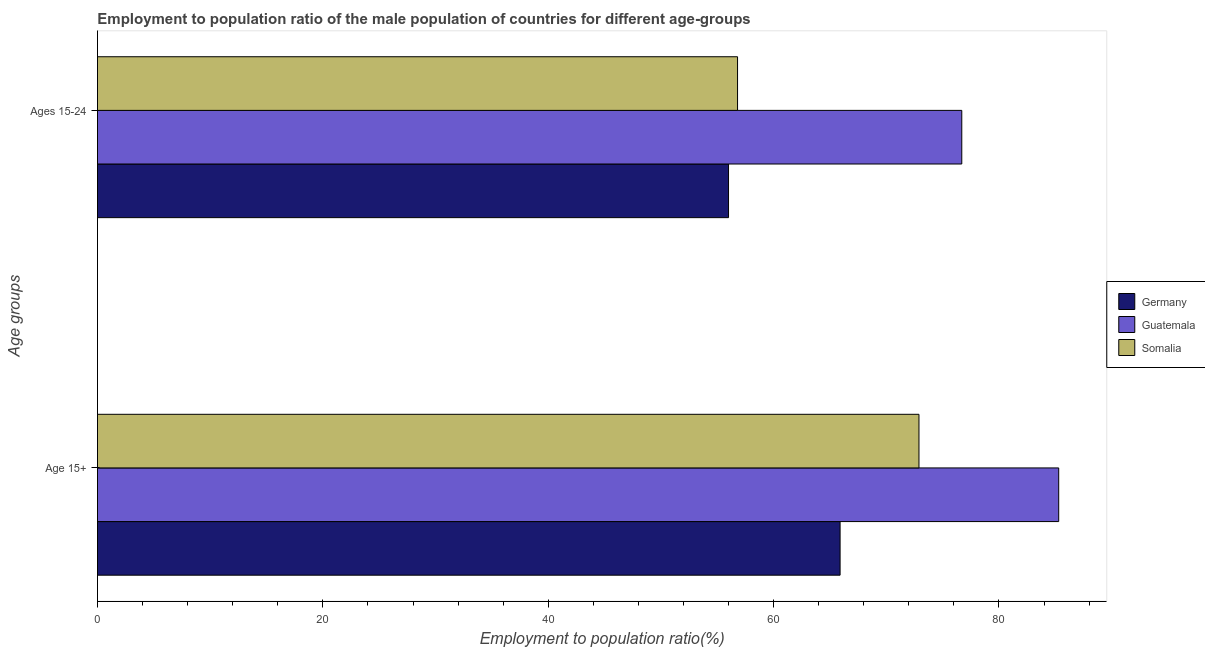How many different coloured bars are there?
Your response must be concise. 3. Are the number of bars per tick equal to the number of legend labels?
Offer a very short reply. Yes. Are the number of bars on each tick of the Y-axis equal?
Offer a very short reply. Yes. How many bars are there on the 2nd tick from the top?
Provide a succinct answer. 3. What is the label of the 2nd group of bars from the top?
Ensure brevity in your answer.  Age 15+. What is the employment to population ratio(age 15+) in Guatemala?
Your answer should be very brief. 85.3. Across all countries, what is the maximum employment to population ratio(age 15-24)?
Provide a succinct answer. 76.7. Across all countries, what is the minimum employment to population ratio(age 15+)?
Your answer should be very brief. 65.9. In which country was the employment to population ratio(age 15+) maximum?
Your answer should be very brief. Guatemala. In which country was the employment to population ratio(age 15+) minimum?
Keep it short and to the point. Germany. What is the total employment to population ratio(age 15-24) in the graph?
Offer a terse response. 189.5. What is the difference between the employment to population ratio(age 15-24) in Somalia and that in Germany?
Make the answer very short. 0.8. What is the difference between the employment to population ratio(age 15+) in Somalia and the employment to population ratio(age 15-24) in Guatemala?
Offer a terse response. -3.8. What is the average employment to population ratio(age 15-24) per country?
Give a very brief answer. 63.17. What is the difference between the employment to population ratio(age 15+) and employment to population ratio(age 15-24) in Guatemala?
Provide a short and direct response. 8.6. What is the ratio of the employment to population ratio(age 15+) in Guatemala to that in Germany?
Make the answer very short. 1.29. Is the employment to population ratio(age 15-24) in Somalia less than that in Germany?
Your response must be concise. No. What does the 1st bar from the top in Ages 15-24 represents?
Provide a succinct answer. Somalia. What does the 1st bar from the bottom in Ages 15-24 represents?
Provide a succinct answer. Germany. How many bars are there?
Keep it short and to the point. 6. How many countries are there in the graph?
Make the answer very short. 3. What is the difference between two consecutive major ticks on the X-axis?
Ensure brevity in your answer.  20. Are the values on the major ticks of X-axis written in scientific E-notation?
Your answer should be compact. No. Does the graph contain any zero values?
Make the answer very short. No. Does the graph contain grids?
Give a very brief answer. No. How are the legend labels stacked?
Provide a succinct answer. Vertical. What is the title of the graph?
Provide a short and direct response. Employment to population ratio of the male population of countries for different age-groups. Does "Macao" appear as one of the legend labels in the graph?
Your response must be concise. No. What is the label or title of the Y-axis?
Provide a short and direct response. Age groups. What is the Employment to population ratio(%) of Germany in Age 15+?
Offer a terse response. 65.9. What is the Employment to population ratio(%) of Guatemala in Age 15+?
Give a very brief answer. 85.3. What is the Employment to population ratio(%) of Somalia in Age 15+?
Offer a terse response. 72.9. What is the Employment to population ratio(%) of Germany in Ages 15-24?
Make the answer very short. 56. What is the Employment to population ratio(%) in Guatemala in Ages 15-24?
Your answer should be very brief. 76.7. What is the Employment to population ratio(%) in Somalia in Ages 15-24?
Offer a very short reply. 56.8. Across all Age groups, what is the maximum Employment to population ratio(%) of Germany?
Offer a very short reply. 65.9. Across all Age groups, what is the maximum Employment to population ratio(%) of Guatemala?
Your answer should be very brief. 85.3. Across all Age groups, what is the maximum Employment to population ratio(%) in Somalia?
Provide a short and direct response. 72.9. Across all Age groups, what is the minimum Employment to population ratio(%) in Germany?
Make the answer very short. 56. Across all Age groups, what is the minimum Employment to population ratio(%) in Guatemala?
Your response must be concise. 76.7. Across all Age groups, what is the minimum Employment to population ratio(%) of Somalia?
Ensure brevity in your answer.  56.8. What is the total Employment to population ratio(%) of Germany in the graph?
Offer a terse response. 121.9. What is the total Employment to population ratio(%) in Guatemala in the graph?
Keep it short and to the point. 162. What is the total Employment to population ratio(%) of Somalia in the graph?
Offer a terse response. 129.7. What is the difference between the Employment to population ratio(%) of Germany in Age 15+ and that in Ages 15-24?
Offer a terse response. 9.9. What is the difference between the Employment to population ratio(%) in Guatemala in Age 15+ and that in Ages 15-24?
Your answer should be compact. 8.6. What is the difference between the Employment to population ratio(%) of Somalia in Age 15+ and that in Ages 15-24?
Ensure brevity in your answer.  16.1. What is the difference between the Employment to population ratio(%) of Germany in Age 15+ and the Employment to population ratio(%) of Somalia in Ages 15-24?
Keep it short and to the point. 9.1. What is the average Employment to population ratio(%) of Germany per Age groups?
Your answer should be compact. 60.95. What is the average Employment to population ratio(%) in Guatemala per Age groups?
Your answer should be very brief. 81. What is the average Employment to population ratio(%) in Somalia per Age groups?
Your answer should be compact. 64.85. What is the difference between the Employment to population ratio(%) in Germany and Employment to population ratio(%) in Guatemala in Age 15+?
Provide a short and direct response. -19.4. What is the difference between the Employment to population ratio(%) in Germany and Employment to population ratio(%) in Somalia in Age 15+?
Provide a succinct answer. -7. What is the difference between the Employment to population ratio(%) of Germany and Employment to population ratio(%) of Guatemala in Ages 15-24?
Your answer should be very brief. -20.7. What is the difference between the Employment to population ratio(%) of Germany and Employment to population ratio(%) of Somalia in Ages 15-24?
Offer a terse response. -0.8. What is the difference between the Employment to population ratio(%) of Guatemala and Employment to population ratio(%) of Somalia in Ages 15-24?
Ensure brevity in your answer.  19.9. What is the ratio of the Employment to population ratio(%) in Germany in Age 15+ to that in Ages 15-24?
Make the answer very short. 1.18. What is the ratio of the Employment to population ratio(%) of Guatemala in Age 15+ to that in Ages 15-24?
Provide a succinct answer. 1.11. What is the ratio of the Employment to population ratio(%) in Somalia in Age 15+ to that in Ages 15-24?
Give a very brief answer. 1.28. What is the difference between the highest and the second highest Employment to population ratio(%) in Germany?
Provide a succinct answer. 9.9. What is the difference between the highest and the second highest Employment to population ratio(%) in Somalia?
Give a very brief answer. 16.1. 